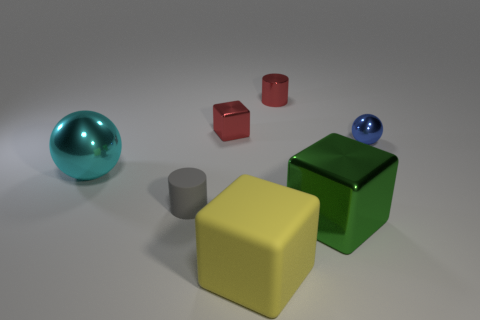What number of big purple metal objects are there?
Keep it short and to the point. 0. Do the big sphere and the ball that is to the right of the tiny gray cylinder have the same material?
Provide a succinct answer. Yes. What number of yellow things are either big blocks or large shiny cubes?
Make the answer very short. 1. What is the size of the green block that is the same material as the large ball?
Your answer should be very brief. Large. How many other small objects have the same shape as the small matte thing?
Provide a short and direct response. 1. Is the number of big yellow rubber cubes that are left of the green metallic object greater than the number of large yellow blocks behind the large yellow rubber block?
Keep it short and to the point. Yes. There is a small metallic cylinder; is its color the same as the cube left of the big matte block?
Ensure brevity in your answer.  Yes. What material is the red cylinder that is the same size as the red cube?
Offer a very short reply. Metal. What number of objects are either yellow blocks or red things that are to the left of the metal cylinder?
Provide a succinct answer. 2. There is a gray matte cylinder; is it the same size as the block in front of the green object?
Offer a terse response. No. 